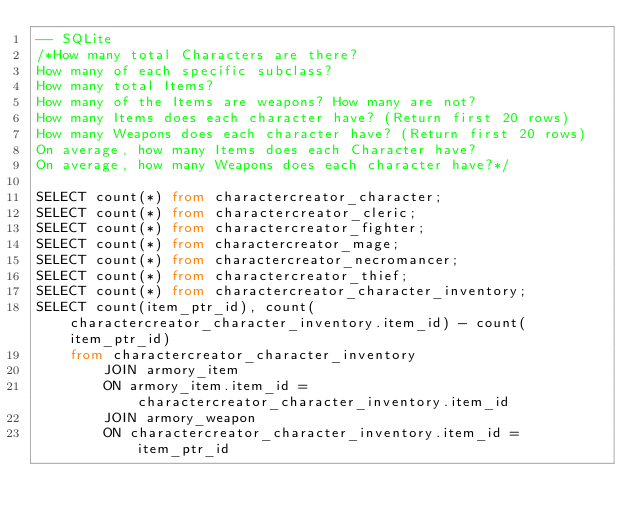Convert code to text. <code><loc_0><loc_0><loc_500><loc_500><_SQL_>-- SQLite
/*How many total Characters are there?
How many of each specific subclass?
How many total Items?
How many of the Items are weapons? How many are not?
How many Items does each character have? (Return first 20 rows)
How many Weapons does each character have? (Return first 20 rows)
On average, how many Items does each Character have?
On average, how many Weapons does each character have?*/

SELECT count(*) from charactercreator_character;
SELECT count(*) from charactercreator_cleric;
SELECT count(*) from charactercreator_fighter;
SELECT count(*) from charactercreator_mage;
SELECT count(*) from charactercreator_necromancer;
SELECT count(*) from charactercreator_thief;
SELECT count(*) from charactercreator_character_inventory;
SELECT count(item_ptr_id), count(charactercreator_character_inventory.item_id) - count(item_ptr_id) 
    from charactercreator_character_inventory  
        JOIN armory_item
        ON armory_item.item_id = charactercreator_character_inventory.item_id
        JOIN armory_weapon
        ON charactercreator_character_inventory.item_id = item_ptr_id 


    </code> 